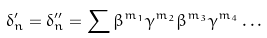Convert formula to latex. <formula><loc_0><loc_0><loc_500><loc_500>\delta _ { n } ^ { \prime } = \delta _ { n } ^ { \prime \prime } = \sum \beta ^ { m _ { 1 } } \gamma ^ { m _ { 2 } } \beta ^ { m _ { 3 } } \gamma ^ { m _ { 4 } } \dots</formula> 